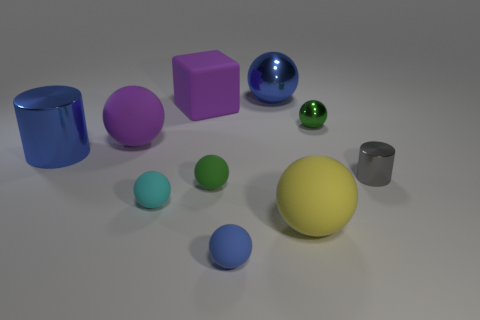Can you tell me about the lighting in this scene? The lighting in this scene is soft and diffused, casting gentle shadows under the objects but not producing any harsh reflections. This suggests an indoor setting with either studio lights or a strong ambient source. Is there any indication of size or scale in the image? Without a familiar reference object, it's difficult to determine the exact size or scale of the objects. However, they could be likened to common play objects such as toy blocks or marbles, based on their simplistic shapes and composition. 